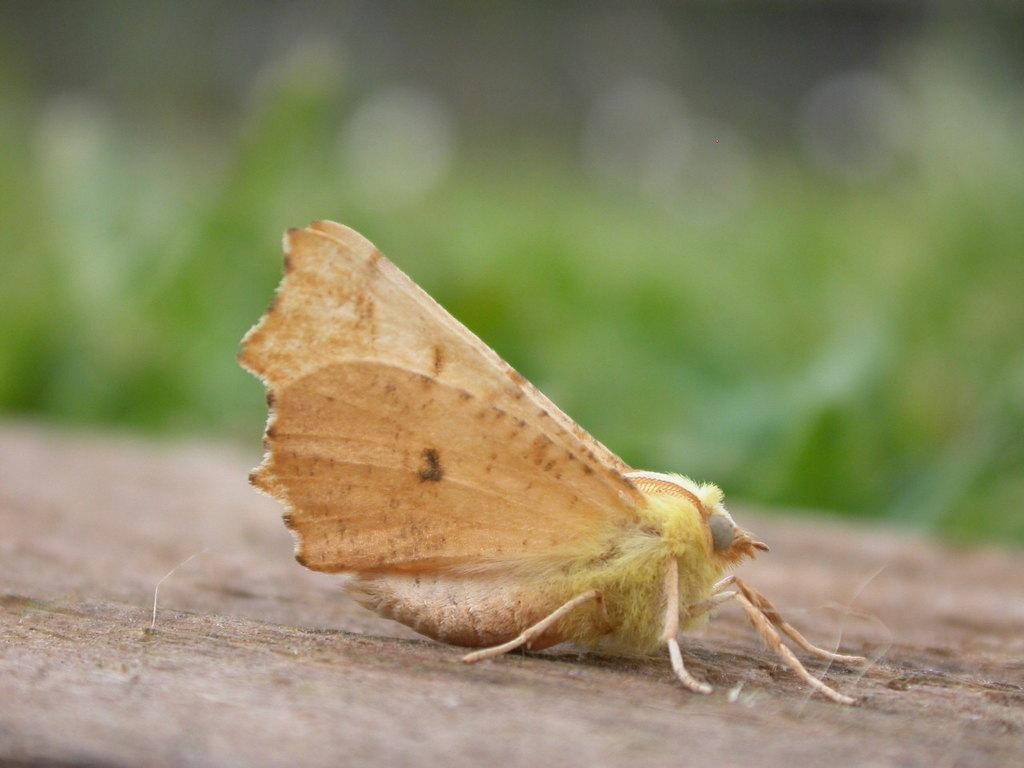What type of insect is on the path in the image? There is a moth on the path in the image. What can be seen in the distance behind the path? There are plants visible in the background of the image. How would you describe the appearance of the background in the image? The background of the image is blurry. What type of wood can be seen on the dock in the image? There is no dock present in the image; it features a moth on a path with plants in the background. 